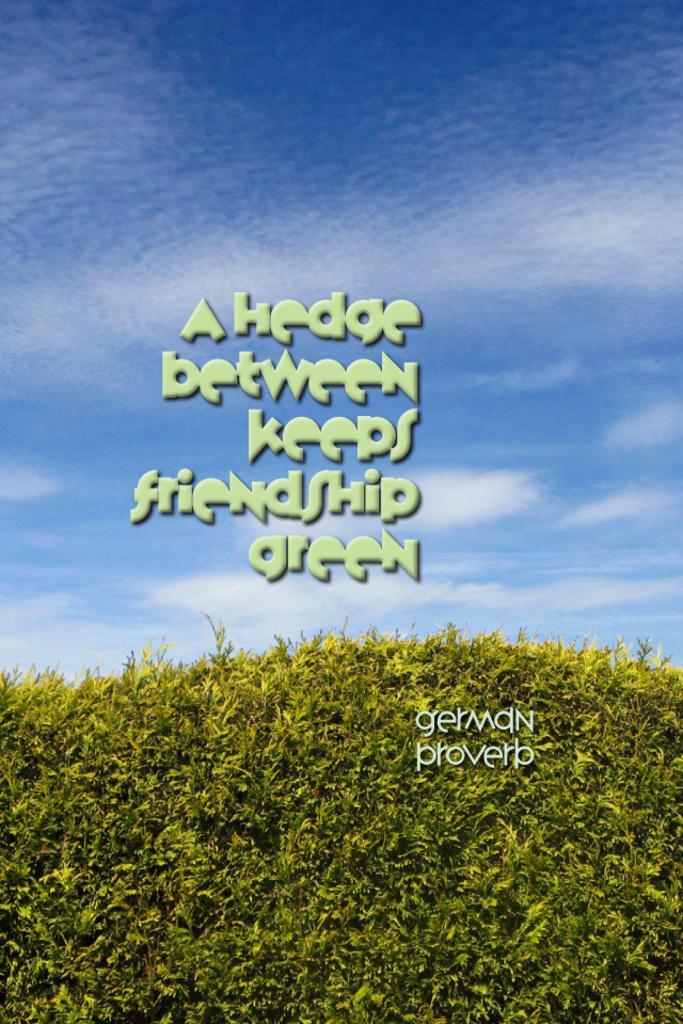In one or two sentences, can you explain what this image depicts? This image consists of a text. At the bottom, there are small plants. In the background, there are clouds in the sky. 